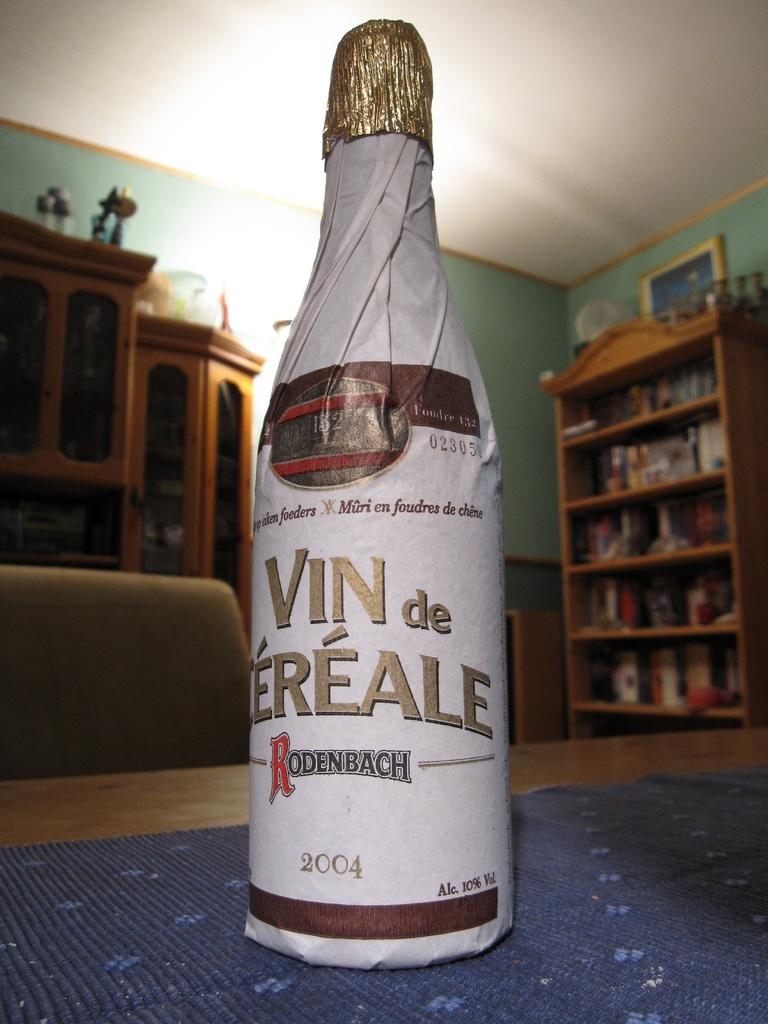Provide a one-sentence caption for the provided image. A bottle of champagne with he brand name Rodenbach. 